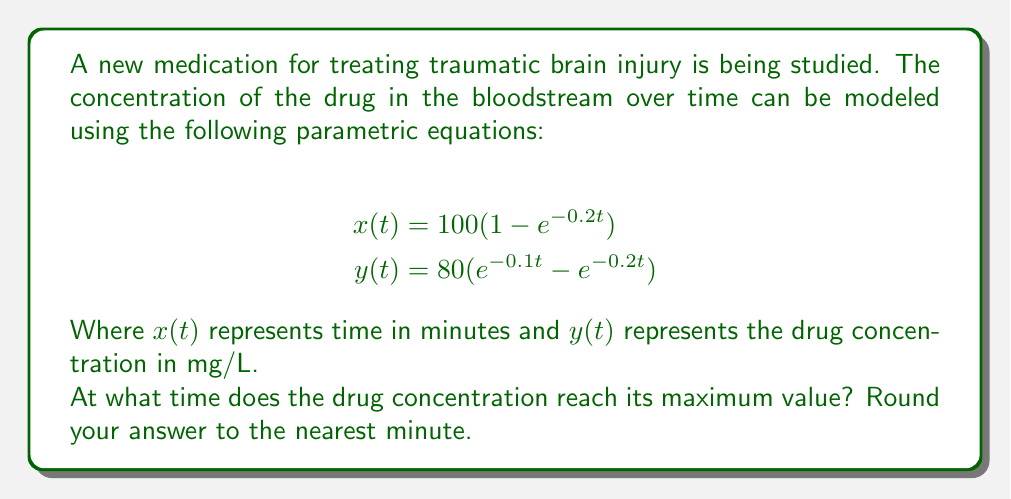Help me with this question. To solve this problem, we need to follow these steps:

1) The maximum concentration occurs when $\frac{dy}{dt} = 0$. However, we don't have $y$ as a function of $x$, so we need to use the chain rule:

   $$\frac{dy}{dx} = \frac{dy/dt}{dx/dt} = 0$$

2) Let's calculate $\frac{dy}{dt}$ and $\frac{dx}{dt}$:

   $$\frac{dy}{dt} = 80(-0.1e^{-0.1t} + 0.2e^{-0.2t})$$
   $$\frac{dx}{dt} = 100(0.2e^{-0.2t})$$

3) Setting $\frac{dy}{dx} = 0$:

   $$\frac{80(-0.1e^{-0.1t} + 0.2e^{-0.2t})}{100(0.2e^{-0.2t})} = 0$$

4) Simplify:

   $$-0.1e^{-0.1t} + 0.2e^{-0.2t} = 0$$
   $$0.2e^{-0.2t} = 0.1e^{-0.1t}$$
   $$2e^{-0.2t} = e^{-0.1t}$$

5) Take natural log of both sides:

   $$\ln(2) - 0.2t = -0.1t$$

6) Solve for $t$:

   $$\ln(2) = 0.1t$$
   $$t = \frac{\ln(2)}{0.1} \approx 6.93$$

7) Rounding to the nearest minute:

   $t \approx 7$ minutes
Answer: 7 minutes 